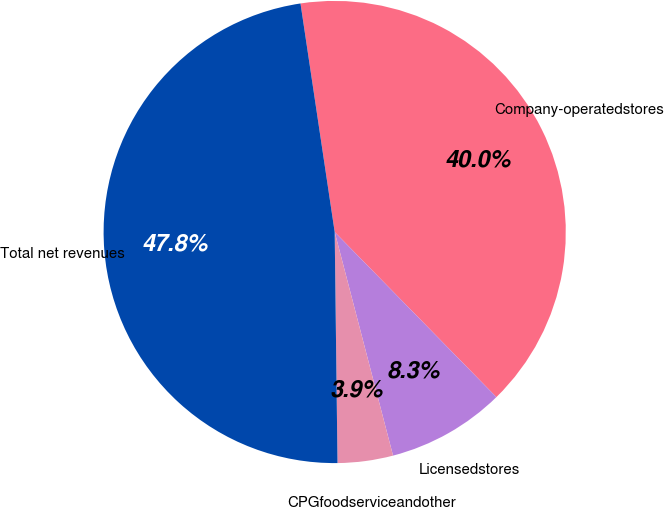Convert chart. <chart><loc_0><loc_0><loc_500><loc_500><pie_chart><fcel>Company-operatedstores<fcel>Licensedstores<fcel>CPGfoodserviceandother<fcel>Total net revenues<nl><fcel>40.03%<fcel>8.27%<fcel>3.87%<fcel>47.83%<nl></chart> 